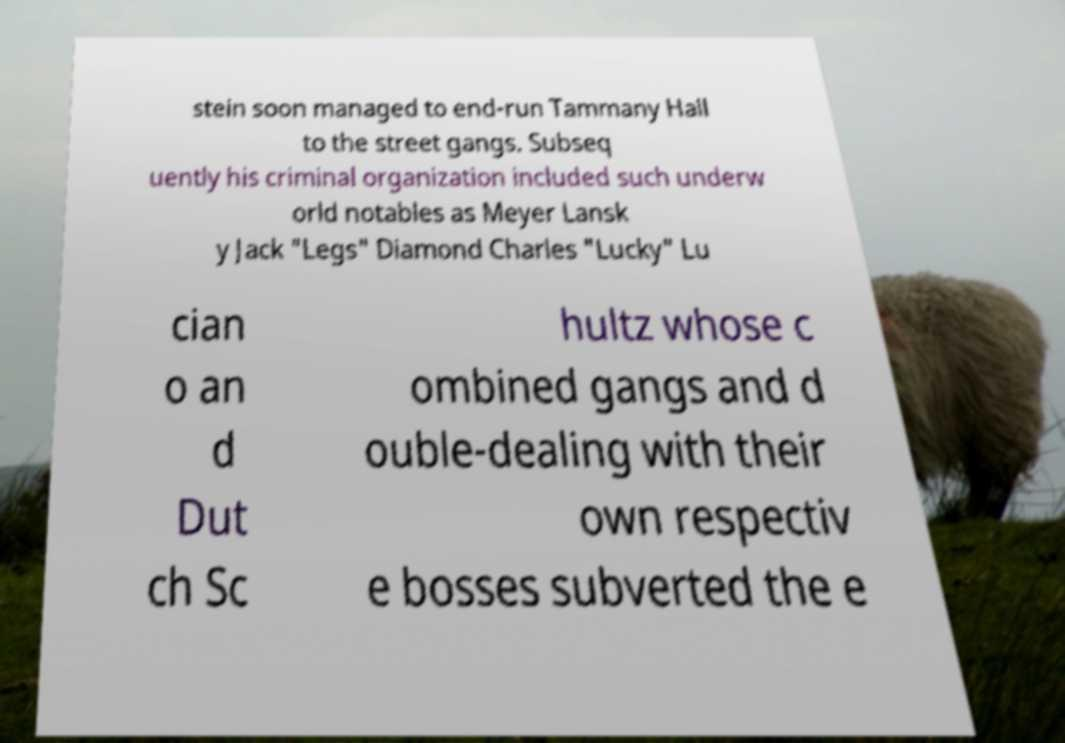Please identify and transcribe the text found in this image. stein soon managed to end-run Tammany Hall to the street gangs. Subseq uently his criminal organization included such underw orld notables as Meyer Lansk y Jack "Legs" Diamond Charles "Lucky" Lu cian o an d Dut ch Sc hultz whose c ombined gangs and d ouble-dealing with their own respectiv e bosses subverted the e 